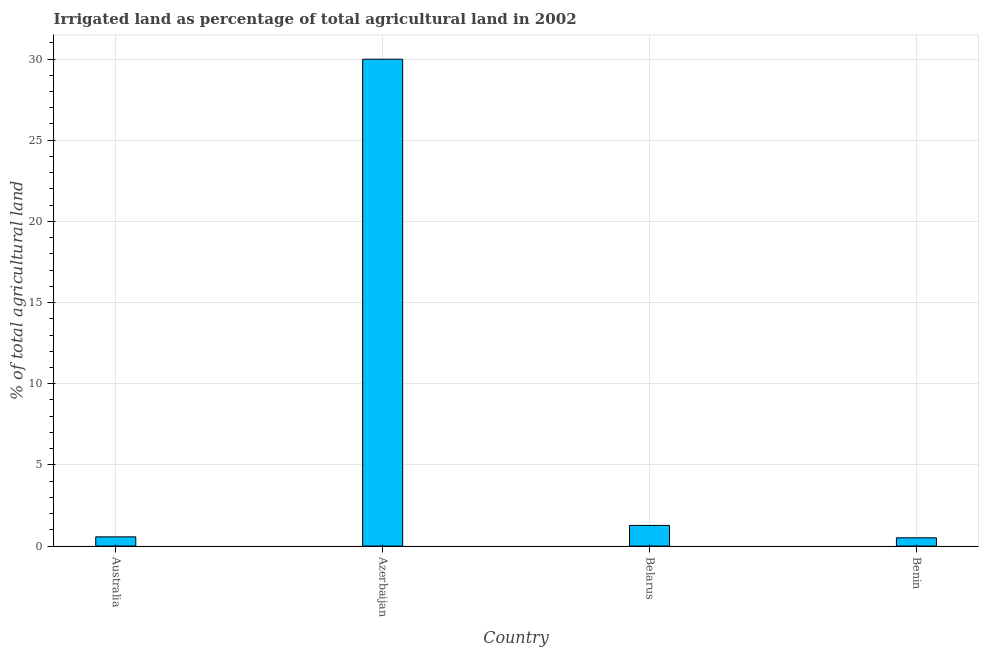Does the graph contain grids?
Ensure brevity in your answer.  Yes. What is the title of the graph?
Provide a short and direct response. Irrigated land as percentage of total agricultural land in 2002. What is the label or title of the X-axis?
Make the answer very short. Country. What is the label or title of the Y-axis?
Offer a very short reply. % of total agricultural land. What is the percentage of agricultural irrigated land in Azerbaijan?
Offer a terse response. 29.99. Across all countries, what is the maximum percentage of agricultural irrigated land?
Your answer should be compact. 29.99. Across all countries, what is the minimum percentage of agricultural irrigated land?
Offer a very short reply. 0.51. In which country was the percentage of agricultural irrigated land maximum?
Offer a terse response. Azerbaijan. In which country was the percentage of agricultural irrigated land minimum?
Offer a very short reply. Benin. What is the sum of the percentage of agricultural irrigated land?
Keep it short and to the point. 32.34. What is the difference between the percentage of agricultural irrigated land in Azerbaijan and Benin?
Provide a short and direct response. 29.48. What is the average percentage of agricultural irrigated land per country?
Provide a succinct answer. 8.09. What is the median percentage of agricultural irrigated land?
Offer a terse response. 0.92. What is the ratio of the percentage of agricultural irrigated land in Belarus to that in Benin?
Your response must be concise. 2.49. Is the difference between the percentage of agricultural irrigated land in Belarus and Benin greater than the difference between any two countries?
Offer a very short reply. No. What is the difference between the highest and the second highest percentage of agricultural irrigated land?
Keep it short and to the point. 28.72. What is the difference between the highest and the lowest percentage of agricultural irrigated land?
Ensure brevity in your answer.  29.48. In how many countries, is the percentage of agricultural irrigated land greater than the average percentage of agricultural irrigated land taken over all countries?
Your answer should be very brief. 1. How many bars are there?
Give a very brief answer. 4. How many countries are there in the graph?
Provide a succinct answer. 4. What is the difference between two consecutive major ticks on the Y-axis?
Ensure brevity in your answer.  5. What is the % of total agricultural land of Australia?
Offer a terse response. 0.57. What is the % of total agricultural land in Azerbaijan?
Keep it short and to the point. 29.99. What is the % of total agricultural land of Belarus?
Give a very brief answer. 1.27. What is the % of total agricultural land of Benin?
Provide a short and direct response. 0.51. What is the difference between the % of total agricultural land in Australia and Azerbaijan?
Provide a short and direct response. -29.42. What is the difference between the % of total agricultural land in Australia and Belarus?
Offer a terse response. -0.7. What is the difference between the % of total agricultural land in Australia and Benin?
Provide a short and direct response. 0.06. What is the difference between the % of total agricultural land in Azerbaijan and Belarus?
Provide a succinct answer. 28.72. What is the difference between the % of total agricultural land in Azerbaijan and Benin?
Offer a very short reply. 29.48. What is the difference between the % of total agricultural land in Belarus and Benin?
Provide a short and direct response. 0.76. What is the ratio of the % of total agricultural land in Australia to that in Azerbaijan?
Offer a terse response. 0.02. What is the ratio of the % of total agricultural land in Australia to that in Belarus?
Your answer should be very brief. 0.45. What is the ratio of the % of total agricultural land in Australia to that in Benin?
Offer a terse response. 1.11. What is the ratio of the % of total agricultural land in Azerbaijan to that in Belarus?
Your answer should be compact. 23.54. What is the ratio of the % of total agricultural land in Azerbaijan to that in Benin?
Offer a terse response. 58.67. What is the ratio of the % of total agricultural land in Belarus to that in Benin?
Your answer should be very brief. 2.49. 